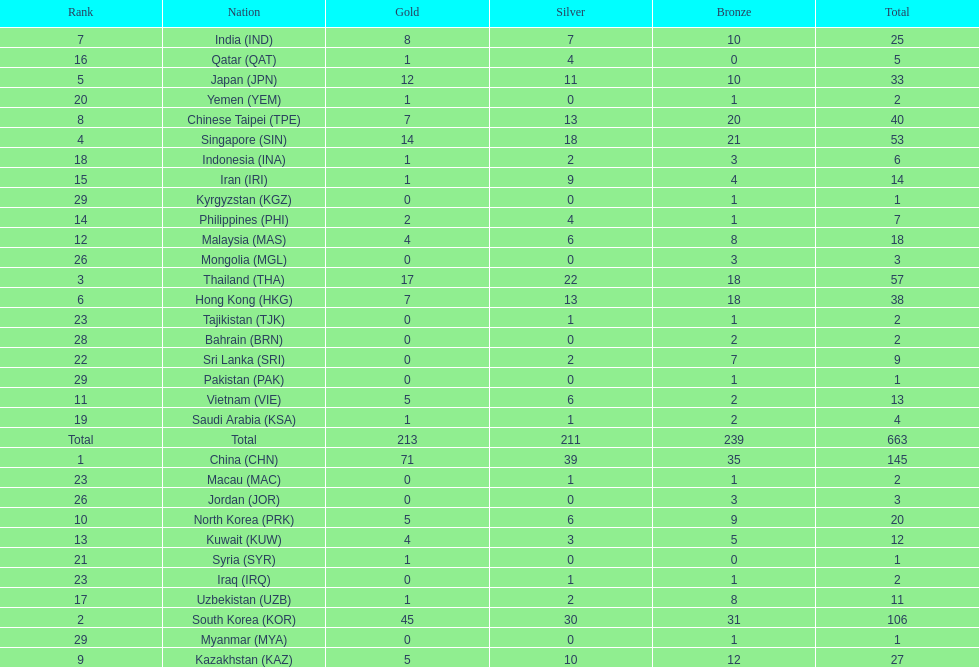Which countries have the same number of silver medals in the asian youth games as north korea? Vietnam (VIE), Malaysia (MAS). 